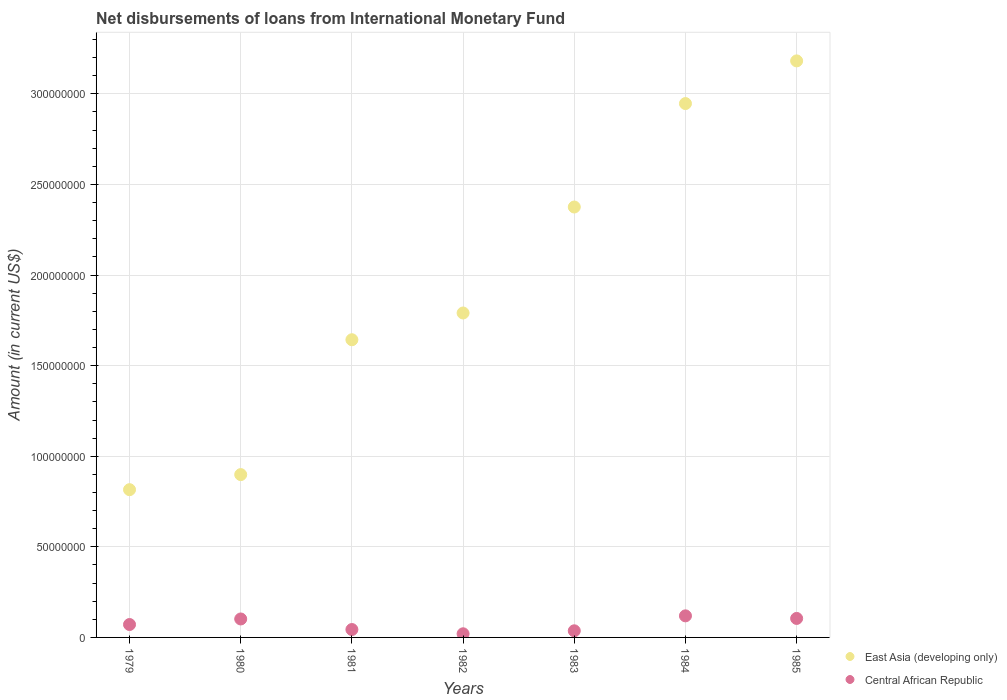How many different coloured dotlines are there?
Make the answer very short. 2. Is the number of dotlines equal to the number of legend labels?
Give a very brief answer. Yes. What is the amount of loans disbursed in Central African Republic in 1980?
Keep it short and to the point. 1.02e+07. Across all years, what is the maximum amount of loans disbursed in East Asia (developing only)?
Your response must be concise. 3.18e+08. Across all years, what is the minimum amount of loans disbursed in East Asia (developing only)?
Your response must be concise. 8.15e+07. In which year was the amount of loans disbursed in East Asia (developing only) maximum?
Make the answer very short. 1985. In which year was the amount of loans disbursed in East Asia (developing only) minimum?
Your answer should be very brief. 1979. What is the total amount of loans disbursed in East Asia (developing only) in the graph?
Your answer should be compact. 1.37e+09. What is the difference between the amount of loans disbursed in East Asia (developing only) in 1979 and that in 1985?
Offer a terse response. -2.37e+08. What is the difference between the amount of loans disbursed in Central African Republic in 1983 and the amount of loans disbursed in East Asia (developing only) in 1980?
Your answer should be compact. -8.62e+07. What is the average amount of loans disbursed in Central African Republic per year?
Offer a terse response. 7.10e+06. In the year 1984, what is the difference between the amount of loans disbursed in East Asia (developing only) and amount of loans disbursed in Central African Republic?
Your response must be concise. 2.83e+08. What is the ratio of the amount of loans disbursed in Central African Republic in 1983 to that in 1985?
Offer a very short reply. 0.35. Is the amount of loans disbursed in Central African Republic in 1980 less than that in 1984?
Your answer should be very brief. Yes. Is the difference between the amount of loans disbursed in East Asia (developing only) in 1979 and 1980 greater than the difference between the amount of loans disbursed in Central African Republic in 1979 and 1980?
Your answer should be compact. No. What is the difference between the highest and the second highest amount of loans disbursed in East Asia (developing only)?
Make the answer very short. 2.35e+07. What is the difference between the highest and the lowest amount of loans disbursed in Central African Republic?
Make the answer very short. 9.90e+06. Does the amount of loans disbursed in East Asia (developing only) monotonically increase over the years?
Your response must be concise. Yes. How many dotlines are there?
Give a very brief answer. 2. How many years are there in the graph?
Offer a very short reply. 7. Are the values on the major ticks of Y-axis written in scientific E-notation?
Your response must be concise. No. Does the graph contain grids?
Give a very brief answer. Yes. How many legend labels are there?
Make the answer very short. 2. How are the legend labels stacked?
Offer a very short reply. Vertical. What is the title of the graph?
Provide a short and direct response. Net disbursements of loans from International Monetary Fund. Does "New Caledonia" appear as one of the legend labels in the graph?
Provide a short and direct response. No. What is the Amount (in current US$) of East Asia (developing only) in 1979?
Provide a succinct answer. 8.15e+07. What is the Amount (in current US$) in Central African Republic in 1979?
Your answer should be very brief. 7.12e+06. What is the Amount (in current US$) of East Asia (developing only) in 1980?
Offer a terse response. 8.99e+07. What is the Amount (in current US$) of Central African Republic in 1980?
Make the answer very short. 1.02e+07. What is the Amount (in current US$) in East Asia (developing only) in 1981?
Offer a very short reply. 1.64e+08. What is the Amount (in current US$) in Central African Republic in 1981?
Keep it short and to the point. 4.36e+06. What is the Amount (in current US$) in East Asia (developing only) in 1982?
Ensure brevity in your answer.  1.79e+08. What is the Amount (in current US$) of Central African Republic in 1982?
Make the answer very short. 2.01e+06. What is the Amount (in current US$) in East Asia (developing only) in 1983?
Your response must be concise. 2.38e+08. What is the Amount (in current US$) in Central African Republic in 1983?
Your answer should be very brief. 3.66e+06. What is the Amount (in current US$) of East Asia (developing only) in 1984?
Give a very brief answer. 2.95e+08. What is the Amount (in current US$) in Central African Republic in 1984?
Keep it short and to the point. 1.19e+07. What is the Amount (in current US$) of East Asia (developing only) in 1985?
Your answer should be very brief. 3.18e+08. What is the Amount (in current US$) in Central African Republic in 1985?
Your response must be concise. 1.05e+07. Across all years, what is the maximum Amount (in current US$) in East Asia (developing only)?
Give a very brief answer. 3.18e+08. Across all years, what is the maximum Amount (in current US$) of Central African Republic?
Give a very brief answer. 1.19e+07. Across all years, what is the minimum Amount (in current US$) of East Asia (developing only)?
Provide a succinct answer. 8.15e+07. Across all years, what is the minimum Amount (in current US$) of Central African Republic?
Keep it short and to the point. 2.01e+06. What is the total Amount (in current US$) in East Asia (developing only) in the graph?
Your response must be concise. 1.37e+09. What is the total Amount (in current US$) of Central African Republic in the graph?
Provide a succinct answer. 4.97e+07. What is the difference between the Amount (in current US$) in East Asia (developing only) in 1979 and that in 1980?
Make the answer very short. -8.32e+06. What is the difference between the Amount (in current US$) of Central African Republic in 1979 and that in 1980?
Your answer should be very brief. -3.07e+06. What is the difference between the Amount (in current US$) in East Asia (developing only) in 1979 and that in 1981?
Make the answer very short. -8.28e+07. What is the difference between the Amount (in current US$) in Central African Republic in 1979 and that in 1981?
Provide a short and direct response. 2.76e+06. What is the difference between the Amount (in current US$) in East Asia (developing only) in 1979 and that in 1982?
Offer a terse response. -9.75e+07. What is the difference between the Amount (in current US$) in Central African Republic in 1979 and that in 1982?
Your answer should be very brief. 5.11e+06. What is the difference between the Amount (in current US$) in East Asia (developing only) in 1979 and that in 1983?
Ensure brevity in your answer.  -1.56e+08. What is the difference between the Amount (in current US$) of Central African Republic in 1979 and that in 1983?
Ensure brevity in your answer.  3.46e+06. What is the difference between the Amount (in current US$) in East Asia (developing only) in 1979 and that in 1984?
Offer a very short reply. -2.13e+08. What is the difference between the Amount (in current US$) in Central African Republic in 1979 and that in 1984?
Offer a terse response. -4.79e+06. What is the difference between the Amount (in current US$) of East Asia (developing only) in 1979 and that in 1985?
Provide a short and direct response. -2.37e+08. What is the difference between the Amount (in current US$) of Central African Republic in 1979 and that in 1985?
Provide a succinct answer. -3.36e+06. What is the difference between the Amount (in current US$) in East Asia (developing only) in 1980 and that in 1981?
Give a very brief answer. -7.44e+07. What is the difference between the Amount (in current US$) of Central African Republic in 1980 and that in 1981?
Give a very brief answer. 5.83e+06. What is the difference between the Amount (in current US$) of East Asia (developing only) in 1980 and that in 1982?
Keep it short and to the point. -8.92e+07. What is the difference between the Amount (in current US$) of Central African Republic in 1980 and that in 1982?
Ensure brevity in your answer.  8.18e+06. What is the difference between the Amount (in current US$) in East Asia (developing only) in 1980 and that in 1983?
Your answer should be compact. -1.48e+08. What is the difference between the Amount (in current US$) in Central African Republic in 1980 and that in 1983?
Offer a very short reply. 6.53e+06. What is the difference between the Amount (in current US$) of East Asia (developing only) in 1980 and that in 1984?
Your answer should be very brief. -2.05e+08. What is the difference between the Amount (in current US$) in Central African Republic in 1980 and that in 1984?
Offer a very short reply. -1.72e+06. What is the difference between the Amount (in current US$) in East Asia (developing only) in 1980 and that in 1985?
Provide a short and direct response. -2.28e+08. What is the difference between the Amount (in current US$) of Central African Republic in 1980 and that in 1985?
Give a very brief answer. -2.96e+05. What is the difference between the Amount (in current US$) in East Asia (developing only) in 1981 and that in 1982?
Make the answer very short. -1.48e+07. What is the difference between the Amount (in current US$) of Central African Republic in 1981 and that in 1982?
Your answer should be compact. 2.35e+06. What is the difference between the Amount (in current US$) of East Asia (developing only) in 1981 and that in 1983?
Offer a terse response. -7.33e+07. What is the difference between the Amount (in current US$) in East Asia (developing only) in 1981 and that in 1984?
Your answer should be very brief. -1.30e+08. What is the difference between the Amount (in current US$) of Central African Republic in 1981 and that in 1984?
Offer a very short reply. -7.55e+06. What is the difference between the Amount (in current US$) of East Asia (developing only) in 1981 and that in 1985?
Offer a terse response. -1.54e+08. What is the difference between the Amount (in current US$) in Central African Republic in 1981 and that in 1985?
Give a very brief answer. -6.13e+06. What is the difference between the Amount (in current US$) in East Asia (developing only) in 1982 and that in 1983?
Make the answer very short. -5.85e+07. What is the difference between the Amount (in current US$) in Central African Republic in 1982 and that in 1983?
Provide a succinct answer. -1.65e+06. What is the difference between the Amount (in current US$) in East Asia (developing only) in 1982 and that in 1984?
Your response must be concise. -1.16e+08. What is the difference between the Amount (in current US$) of Central African Republic in 1982 and that in 1984?
Ensure brevity in your answer.  -9.90e+06. What is the difference between the Amount (in current US$) of East Asia (developing only) in 1982 and that in 1985?
Your answer should be very brief. -1.39e+08. What is the difference between the Amount (in current US$) of Central African Republic in 1982 and that in 1985?
Provide a short and direct response. -8.47e+06. What is the difference between the Amount (in current US$) in East Asia (developing only) in 1983 and that in 1984?
Give a very brief answer. -5.71e+07. What is the difference between the Amount (in current US$) in Central African Republic in 1983 and that in 1984?
Provide a succinct answer. -8.25e+06. What is the difference between the Amount (in current US$) of East Asia (developing only) in 1983 and that in 1985?
Provide a succinct answer. -8.06e+07. What is the difference between the Amount (in current US$) in Central African Republic in 1983 and that in 1985?
Offer a terse response. -6.83e+06. What is the difference between the Amount (in current US$) of East Asia (developing only) in 1984 and that in 1985?
Give a very brief answer. -2.35e+07. What is the difference between the Amount (in current US$) in Central African Republic in 1984 and that in 1985?
Provide a succinct answer. 1.42e+06. What is the difference between the Amount (in current US$) in East Asia (developing only) in 1979 and the Amount (in current US$) in Central African Republic in 1980?
Give a very brief answer. 7.14e+07. What is the difference between the Amount (in current US$) in East Asia (developing only) in 1979 and the Amount (in current US$) in Central African Republic in 1981?
Keep it short and to the point. 7.72e+07. What is the difference between the Amount (in current US$) in East Asia (developing only) in 1979 and the Amount (in current US$) in Central African Republic in 1982?
Your response must be concise. 7.95e+07. What is the difference between the Amount (in current US$) in East Asia (developing only) in 1979 and the Amount (in current US$) in Central African Republic in 1983?
Your answer should be compact. 7.79e+07. What is the difference between the Amount (in current US$) in East Asia (developing only) in 1979 and the Amount (in current US$) in Central African Republic in 1984?
Keep it short and to the point. 6.96e+07. What is the difference between the Amount (in current US$) of East Asia (developing only) in 1979 and the Amount (in current US$) of Central African Republic in 1985?
Provide a short and direct response. 7.11e+07. What is the difference between the Amount (in current US$) of East Asia (developing only) in 1980 and the Amount (in current US$) of Central African Republic in 1981?
Provide a short and direct response. 8.55e+07. What is the difference between the Amount (in current US$) of East Asia (developing only) in 1980 and the Amount (in current US$) of Central African Republic in 1982?
Provide a short and direct response. 8.79e+07. What is the difference between the Amount (in current US$) of East Asia (developing only) in 1980 and the Amount (in current US$) of Central African Republic in 1983?
Ensure brevity in your answer.  8.62e+07. What is the difference between the Amount (in current US$) of East Asia (developing only) in 1980 and the Amount (in current US$) of Central African Republic in 1984?
Your response must be concise. 7.80e+07. What is the difference between the Amount (in current US$) in East Asia (developing only) in 1980 and the Amount (in current US$) in Central African Republic in 1985?
Keep it short and to the point. 7.94e+07. What is the difference between the Amount (in current US$) of East Asia (developing only) in 1981 and the Amount (in current US$) of Central African Republic in 1982?
Offer a terse response. 1.62e+08. What is the difference between the Amount (in current US$) of East Asia (developing only) in 1981 and the Amount (in current US$) of Central African Republic in 1983?
Make the answer very short. 1.61e+08. What is the difference between the Amount (in current US$) of East Asia (developing only) in 1981 and the Amount (in current US$) of Central African Republic in 1984?
Offer a very short reply. 1.52e+08. What is the difference between the Amount (in current US$) in East Asia (developing only) in 1981 and the Amount (in current US$) in Central African Republic in 1985?
Provide a succinct answer. 1.54e+08. What is the difference between the Amount (in current US$) of East Asia (developing only) in 1982 and the Amount (in current US$) of Central African Republic in 1983?
Give a very brief answer. 1.75e+08. What is the difference between the Amount (in current US$) in East Asia (developing only) in 1982 and the Amount (in current US$) in Central African Republic in 1984?
Your response must be concise. 1.67e+08. What is the difference between the Amount (in current US$) of East Asia (developing only) in 1982 and the Amount (in current US$) of Central African Republic in 1985?
Provide a short and direct response. 1.69e+08. What is the difference between the Amount (in current US$) in East Asia (developing only) in 1983 and the Amount (in current US$) in Central African Republic in 1984?
Provide a short and direct response. 2.26e+08. What is the difference between the Amount (in current US$) in East Asia (developing only) in 1983 and the Amount (in current US$) in Central African Republic in 1985?
Give a very brief answer. 2.27e+08. What is the difference between the Amount (in current US$) in East Asia (developing only) in 1984 and the Amount (in current US$) in Central African Republic in 1985?
Your answer should be compact. 2.84e+08. What is the average Amount (in current US$) in East Asia (developing only) per year?
Your answer should be very brief. 1.95e+08. What is the average Amount (in current US$) in Central African Republic per year?
Provide a short and direct response. 7.10e+06. In the year 1979, what is the difference between the Amount (in current US$) in East Asia (developing only) and Amount (in current US$) in Central African Republic?
Provide a succinct answer. 7.44e+07. In the year 1980, what is the difference between the Amount (in current US$) of East Asia (developing only) and Amount (in current US$) of Central African Republic?
Make the answer very short. 7.97e+07. In the year 1981, what is the difference between the Amount (in current US$) of East Asia (developing only) and Amount (in current US$) of Central African Republic?
Ensure brevity in your answer.  1.60e+08. In the year 1982, what is the difference between the Amount (in current US$) of East Asia (developing only) and Amount (in current US$) of Central African Republic?
Offer a terse response. 1.77e+08. In the year 1983, what is the difference between the Amount (in current US$) of East Asia (developing only) and Amount (in current US$) of Central African Republic?
Provide a short and direct response. 2.34e+08. In the year 1984, what is the difference between the Amount (in current US$) of East Asia (developing only) and Amount (in current US$) of Central African Republic?
Ensure brevity in your answer.  2.83e+08. In the year 1985, what is the difference between the Amount (in current US$) in East Asia (developing only) and Amount (in current US$) in Central African Republic?
Ensure brevity in your answer.  3.08e+08. What is the ratio of the Amount (in current US$) in East Asia (developing only) in 1979 to that in 1980?
Ensure brevity in your answer.  0.91. What is the ratio of the Amount (in current US$) in Central African Republic in 1979 to that in 1980?
Your answer should be very brief. 0.7. What is the ratio of the Amount (in current US$) in East Asia (developing only) in 1979 to that in 1981?
Provide a short and direct response. 0.5. What is the ratio of the Amount (in current US$) in Central African Republic in 1979 to that in 1981?
Your answer should be compact. 1.63. What is the ratio of the Amount (in current US$) of East Asia (developing only) in 1979 to that in 1982?
Keep it short and to the point. 0.46. What is the ratio of the Amount (in current US$) in Central African Republic in 1979 to that in 1982?
Make the answer very short. 3.54. What is the ratio of the Amount (in current US$) in East Asia (developing only) in 1979 to that in 1983?
Your response must be concise. 0.34. What is the ratio of the Amount (in current US$) of Central African Republic in 1979 to that in 1983?
Keep it short and to the point. 1.95. What is the ratio of the Amount (in current US$) in East Asia (developing only) in 1979 to that in 1984?
Offer a very short reply. 0.28. What is the ratio of the Amount (in current US$) in Central African Republic in 1979 to that in 1984?
Your answer should be compact. 0.6. What is the ratio of the Amount (in current US$) in East Asia (developing only) in 1979 to that in 1985?
Your response must be concise. 0.26. What is the ratio of the Amount (in current US$) of Central African Republic in 1979 to that in 1985?
Give a very brief answer. 0.68. What is the ratio of the Amount (in current US$) of East Asia (developing only) in 1980 to that in 1981?
Your answer should be compact. 0.55. What is the ratio of the Amount (in current US$) of Central African Republic in 1980 to that in 1981?
Offer a terse response. 2.34. What is the ratio of the Amount (in current US$) in East Asia (developing only) in 1980 to that in 1982?
Your answer should be very brief. 0.5. What is the ratio of the Amount (in current US$) in Central African Republic in 1980 to that in 1982?
Keep it short and to the point. 5.07. What is the ratio of the Amount (in current US$) of East Asia (developing only) in 1980 to that in 1983?
Offer a very short reply. 0.38. What is the ratio of the Amount (in current US$) of Central African Republic in 1980 to that in 1983?
Your answer should be compact. 2.79. What is the ratio of the Amount (in current US$) in East Asia (developing only) in 1980 to that in 1984?
Keep it short and to the point. 0.3. What is the ratio of the Amount (in current US$) in Central African Republic in 1980 to that in 1984?
Your response must be concise. 0.86. What is the ratio of the Amount (in current US$) in East Asia (developing only) in 1980 to that in 1985?
Provide a short and direct response. 0.28. What is the ratio of the Amount (in current US$) of Central African Republic in 1980 to that in 1985?
Provide a succinct answer. 0.97. What is the ratio of the Amount (in current US$) of East Asia (developing only) in 1981 to that in 1982?
Your answer should be very brief. 0.92. What is the ratio of the Amount (in current US$) in Central African Republic in 1981 to that in 1982?
Provide a succinct answer. 2.17. What is the ratio of the Amount (in current US$) in East Asia (developing only) in 1981 to that in 1983?
Your response must be concise. 0.69. What is the ratio of the Amount (in current US$) of Central African Republic in 1981 to that in 1983?
Your response must be concise. 1.19. What is the ratio of the Amount (in current US$) of East Asia (developing only) in 1981 to that in 1984?
Your response must be concise. 0.56. What is the ratio of the Amount (in current US$) in Central African Republic in 1981 to that in 1984?
Provide a short and direct response. 0.37. What is the ratio of the Amount (in current US$) of East Asia (developing only) in 1981 to that in 1985?
Make the answer very short. 0.52. What is the ratio of the Amount (in current US$) of Central African Republic in 1981 to that in 1985?
Ensure brevity in your answer.  0.42. What is the ratio of the Amount (in current US$) in East Asia (developing only) in 1982 to that in 1983?
Your response must be concise. 0.75. What is the ratio of the Amount (in current US$) of Central African Republic in 1982 to that in 1983?
Ensure brevity in your answer.  0.55. What is the ratio of the Amount (in current US$) of East Asia (developing only) in 1982 to that in 1984?
Provide a short and direct response. 0.61. What is the ratio of the Amount (in current US$) of Central African Republic in 1982 to that in 1984?
Ensure brevity in your answer.  0.17. What is the ratio of the Amount (in current US$) in East Asia (developing only) in 1982 to that in 1985?
Your answer should be compact. 0.56. What is the ratio of the Amount (in current US$) of Central African Republic in 1982 to that in 1985?
Give a very brief answer. 0.19. What is the ratio of the Amount (in current US$) in East Asia (developing only) in 1983 to that in 1984?
Your answer should be very brief. 0.81. What is the ratio of the Amount (in current US$) of Central African Republic in 1983 to that in 1984?
Your answer should be compact. 0.31. What is the ratio of the Amount (in current US$) of East Asia (developing only) in 1983 to that in 1985?
Offer a very short reply. 0.75. What is the ratio of the Amount (in current US$) in Central African Republic in 1983 to that in 1985?
Keep it short and to the point. 0.35. What is the ratio of the Amount (in current US$) in East Asia (developing only) in 1984 to that in 1985?
Your answer should be very brief. 0.93. What is the ratio of the Amount (in current US$) in Central African Republic in 1984 to that in 1985?
Give a very brief answer. 1.14. What is the difference between the highest and the second highest Amount (in current US$) in East Asia (developing only)?
Offer a terse response. 2.35e+07. What is the difference between the highest and the second highest Amount (in current US$) of Central African Republic?
Offer a terse response. 1.42e+06. What is the difference between the highest and the lowest Amount (in current US$) of East Asia (developing only)?
Make the answer very short. 2.37e+08. What is the difference between the highest and the lowest Amount (in current US$) of Central African Republic?
Ensure brevity in your answer.  9.90e+06. 